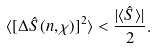<formula> <loc_0><loc_0><loc_500><loc_500>\langle [ \Delta \hat { S } ( { n } , \chi ) ] ^ { 2 } \rangle < \frac { | \langle \hat { S } \rangle | } { 2 } .</formula> 